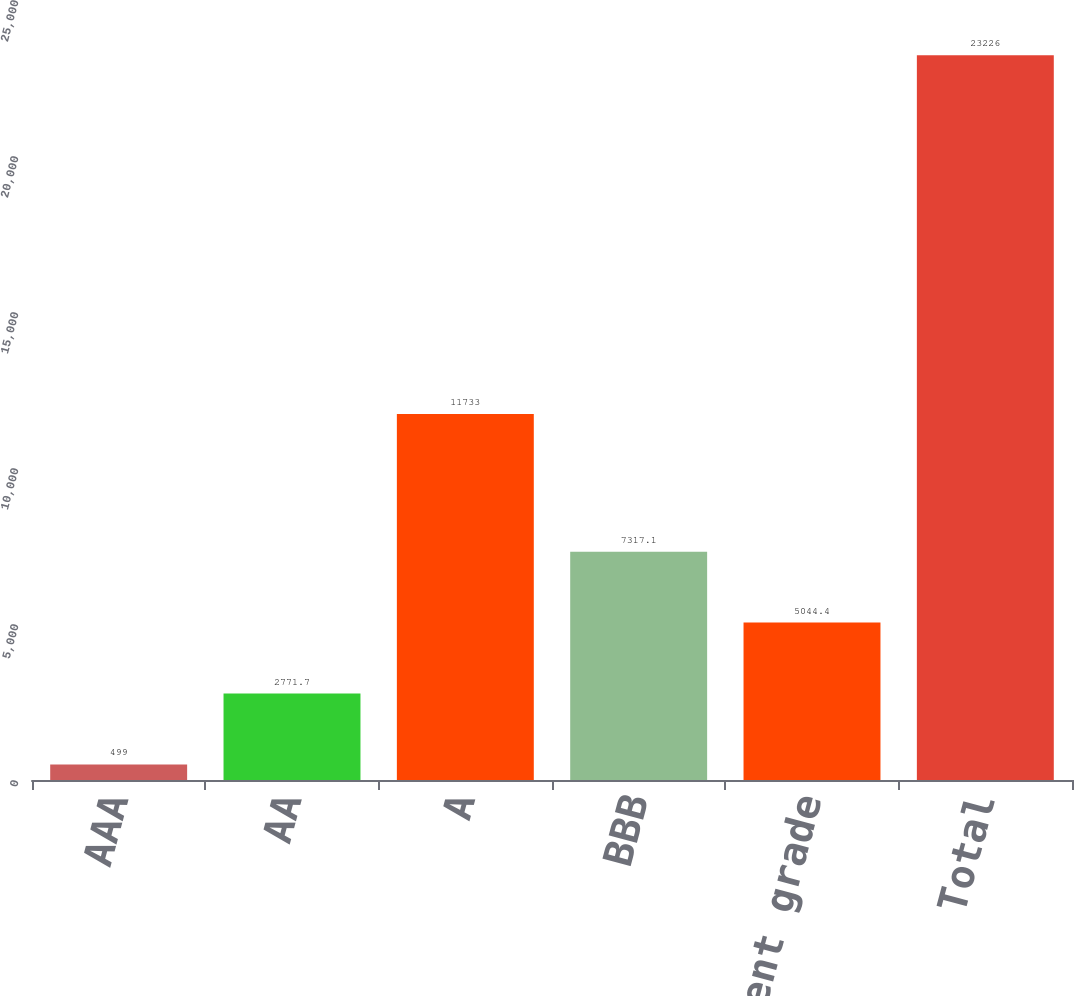<chart> <loc_0><loc_0><loc_500><loc_500><bar_chart><fcel>AAA<fcel>AA<fcel>A<fcel>BBB<fcel>Non-investment grade<fcel>Total<nl><fcel>499<fcel>2771.7<fcel>11733<fcel>7317.1<fcel>5044.4<fcel>23226<nl></chart> 